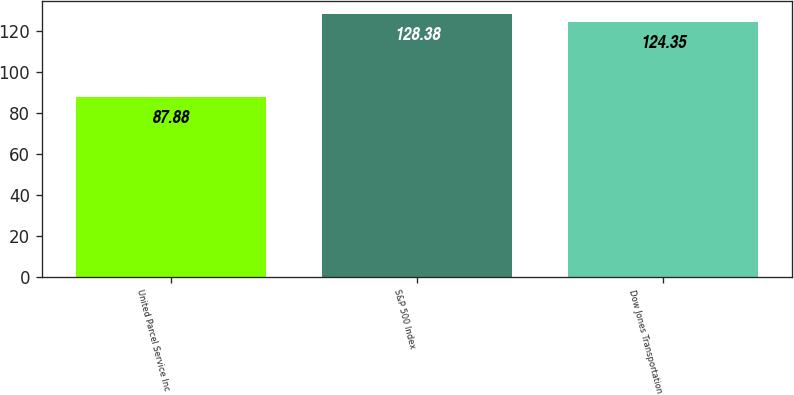Convert chart. <chart><loc_0><loc_0><loc_500><loc_500><bar_chart><fcel>United Parcel Service Inc<fcel>S&P 500 Index<fcel>Dow Jones Transportation<nl><fcel>87.88<fcel>128.38<fcel>124.35<nl></chart> 